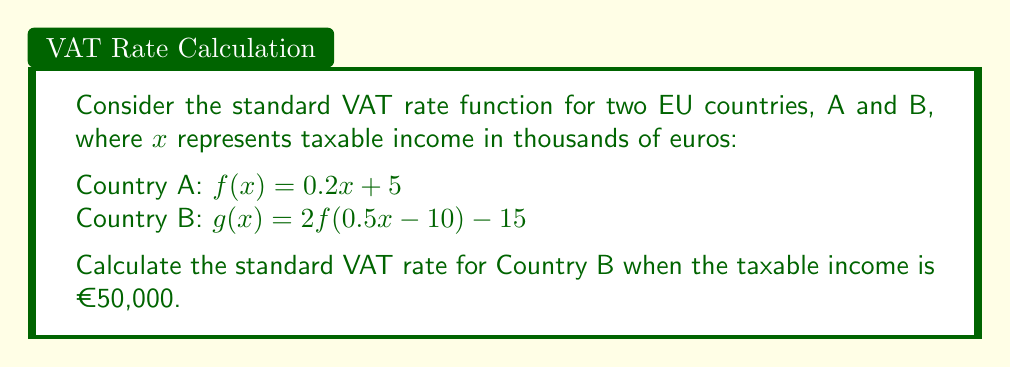Show me your answer to this math problem. Let's approach this step-by-step:

1) We start with the function for Country A: $f(x) = 0.2x + 5$

2) Country B's function is a transformation of Country A's function:
   $g(x) = 2f(0.5x - 10) - 15$

3) We need to find $g(50)$ since the taxable income is €50,000 (50 in thousands of euros)

4) Let's work from the inside out:
   a) First, calculate $0.5x - 10$:
      $0.5(50) - 10 = 25 - 10 = 15$

   b) Now we need to find $f(15)$:
      $f(15) = 0.2(15) + 5 = 3 + 5 = 8$

   c) Next, we multiply this by 2:
      $2(8) = 16$

   d) Finally, we subtract 15:
      $16 - 15 = 1$

5) Therefore, $g(50) = 1$

This means that for a taxable income of €50,000, the standard VAT rate in Country B is €1,000.
Answer: €1,000 